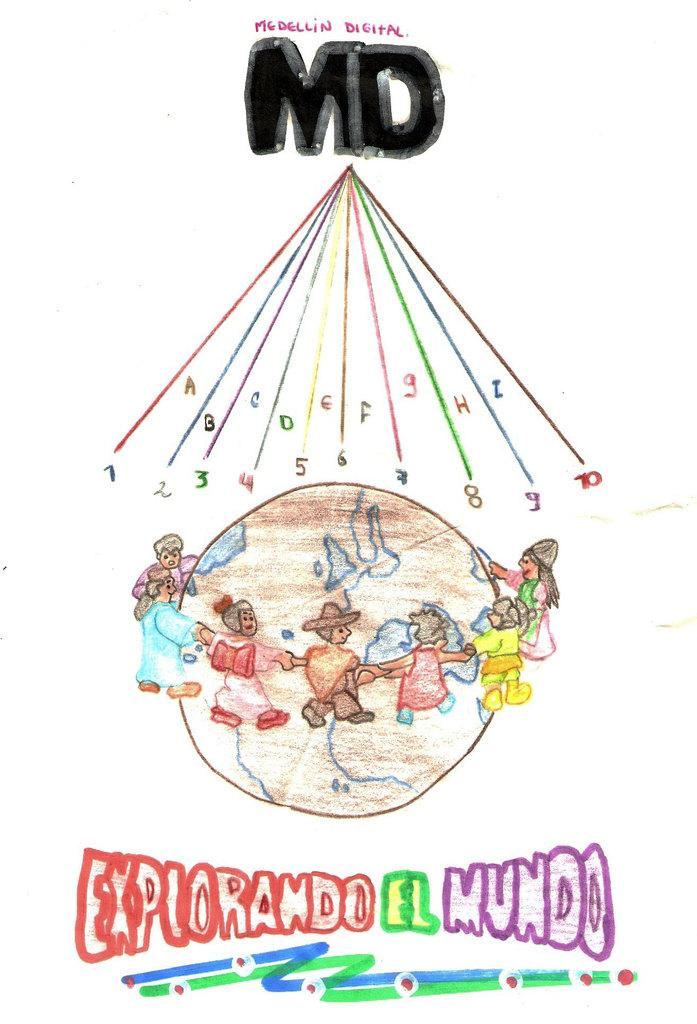<image>
Create a compact narrative representing the image presented. A drawing of people holding hands around a globe with the message Explorando el Mundo. 